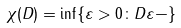<formula> <loc_0><loc_0><loc_500><loc_500>\chi ( D ) = \inf \{ \varepsilon > 0 \colon D \varepsilon - \}</formula> 